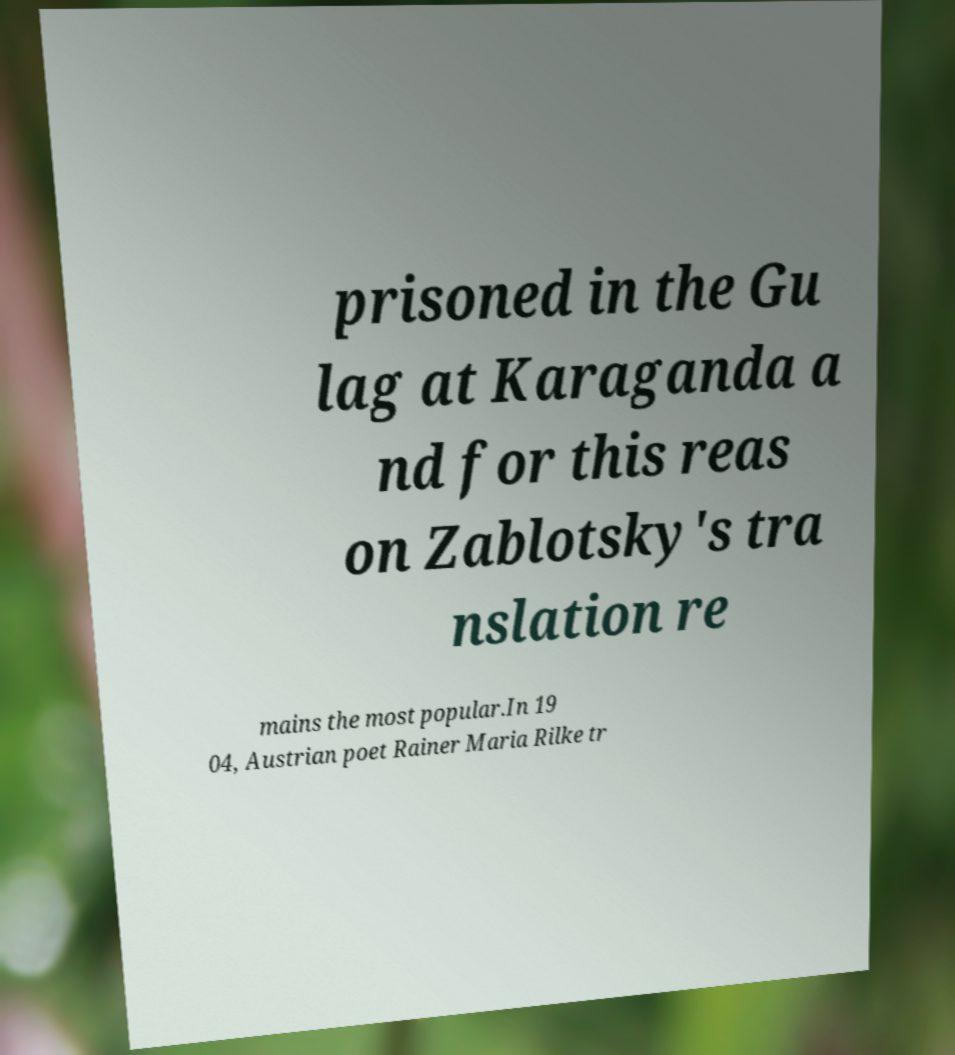Please identify and transcribe the text found in this image. prisoned in the Gu lag at Karaganda a nd for this reas on Zablotsky's tra nslation re mains the most popular.In 19 04, Austrian poet Rainer Maria Rilke tr 